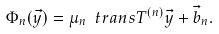<formula> <loc_0><loc_0><loc_500><loc_500>\Phi _ { n } ( \vec { y } ) = \mu _ { n } \ t r a n s T ^ { ( n ) } \vec { y } + \vec { b } _ { n } .</formula> 